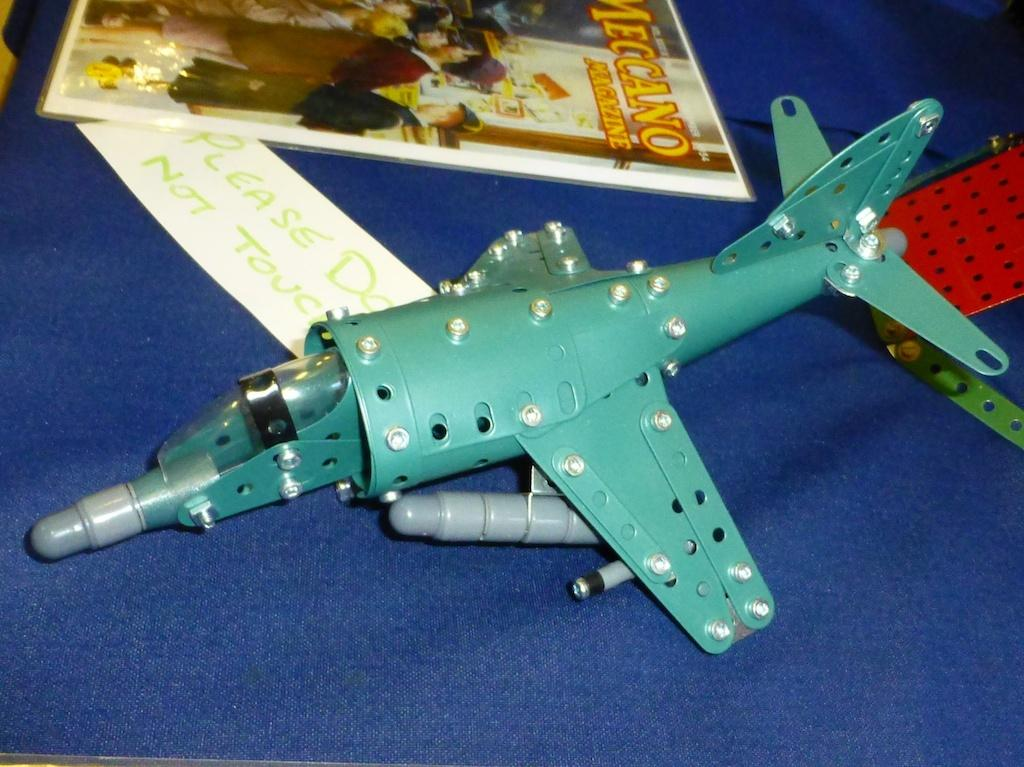<image>
Render a clear and concise summary of the photo. A toy airplane with a sign reading please do not touch 